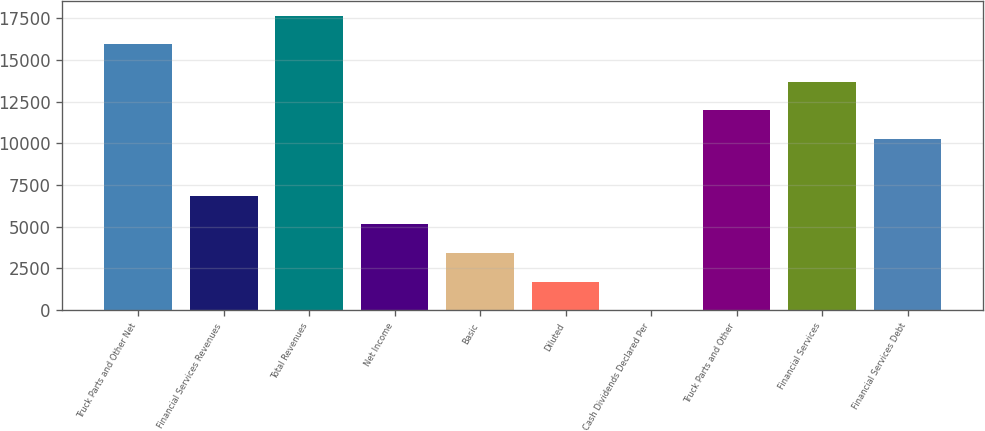<chart> <loc_0><loc_0><loc_500><loc_500><bar_chart><fcel>Truck Parts and Other Net<fcel>Financial Services Revenues<fcel>Total Revenues<fcel>Net Income<fcel>Basic<fcel>Diluted<fcel>Cash Dividends Declared Per<fcel>Truck Parts and Other<fcel>Financial Services<fcel>Financial Services Debt<nl><fcel>15948.9<fcel>6850.54<fcel>17661.1<fcel>5138.33<fcel>3426.12<fcel>1713.91<fcel>1.7<fcel>11987.2<fcel>13699.4<fcel>10275<nl></chart> 